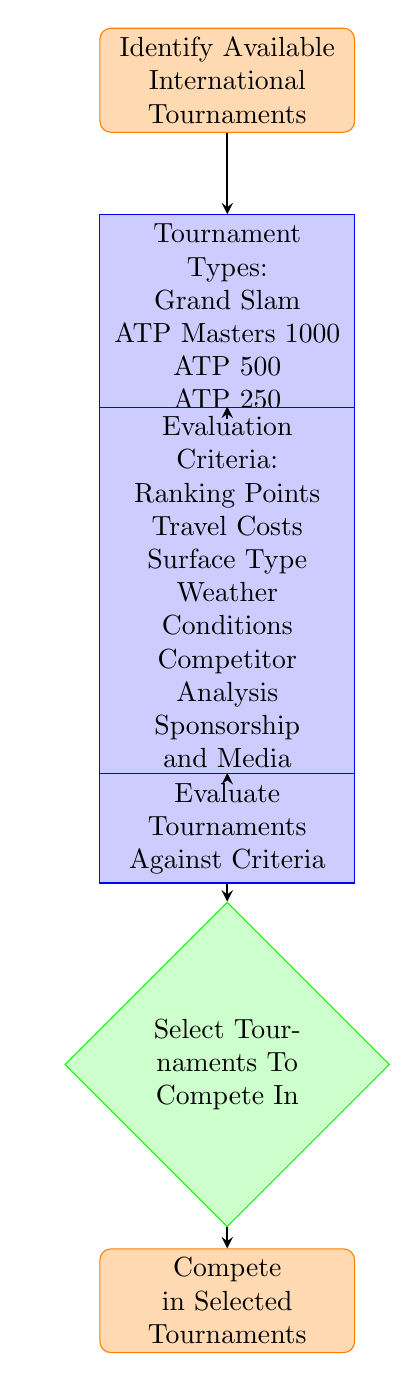What is the starting point of the process? The starting point is indicated at the top of the diagram and it is "Identify Available International Tournaments."
Answer: Identify Available International Tournaments How many types of tournaments are listed? The list of tournament types can be counted in the "Tournament Types" process node, which includes four types: Grand Slam, ATP Masters 1000, ATP 500, and ATP 250.
Answer: Four What are the criteria assessed for tournament selection? The criteria for evaluation are shown in the "Evaluation Criteria" process node and they are: Ranking Points, Travel Costs, Surface Type, Weather Conditions, Competitor Analysis, and Sponsorship and Media.
Answer: Ranking Points, Travel Costs, Surface Type, Weather Conditions, Competitor Analysis, Sponsorship and Media What happens after evaluating tournaments? The flow of the diagram shows that after evaluating the tournaments against the established criteria, the next step is to "Select Tournaments To Compete In."
Answer: Select Tournaments To Compete In If all criteria are met, what is the final action? The last node of the diagram indicates that once tournaments are selected, the final action is to "Compete in Selected Tournaments."
Answer: Compete in Selected Tournaments What is the relationship between the "Evaluation Criteria" and "Evaluate Tournaments Against Criteria"? The diagram indicates that the "Evaluation Criteria" process leads directly to the "Evaluate Tournaments Against Criteria," implying that the criteria must be applied in the evaluation step.
Answer: Directly leads to What would be a reason to consider "Travel Costs"? Travel Costs are one of the criteria listed for evaluating which tournaments to compete in. This indicates the importance of financial considerations when selecting tournaments.
Answer: Financial consideration What does the evaluation process entail? The "Evaluate Tournaments Against Criteria" process implies a comparative analysis of available tournaments based on the set criteria, but it does not detail specific measures taken during evaluation.
Answer: Comparative analysis Which tournament type is at the highest prestige level? Among the listed tournament types, "Grand Slam" is considered the highest prestige level due to its significant ranking points and history in the tennis circuit.
Answer: Grand Slam 